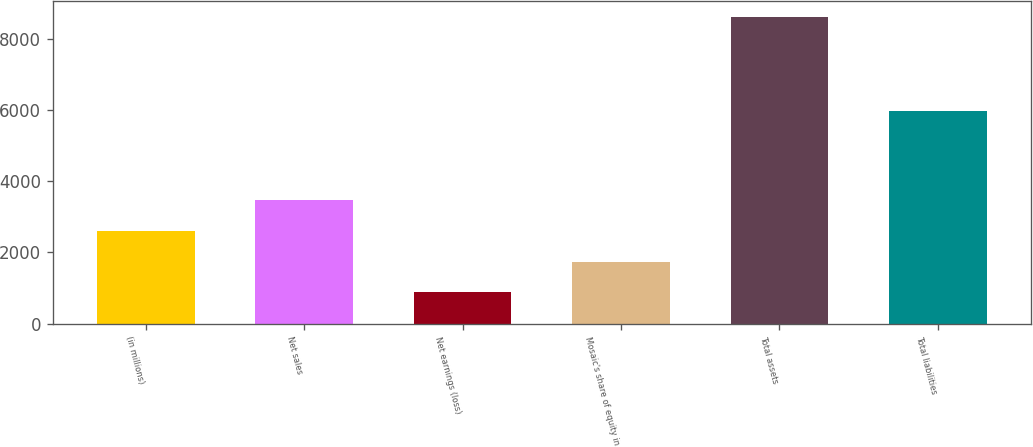<chart> <loc_0><loc_0><loc_500><loc_500><bar_chart><fcel>(in millions)<fcel>Net sales<fcel>Net earnings (loss)<fcel>Mosaic's share of equity in<fcel>Total assets<fcel>Total liabilities<nl><fcel>2598.77<fcel>3459.46<fcel>877.39<fcel>1738.08<fcel>8623.6<fcel>5971.9<nl></chart> 